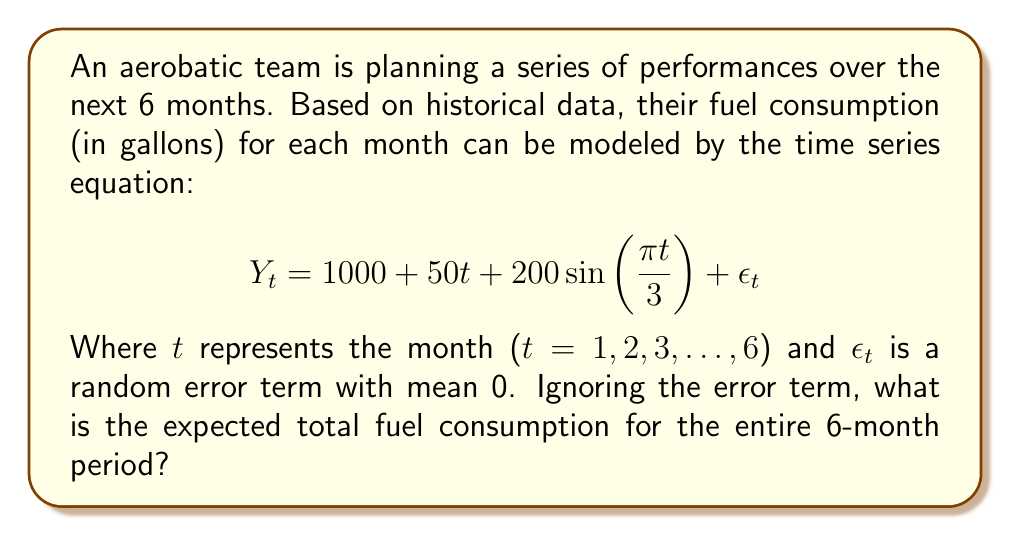Can you solve this math problem? To solve this problem, we need to follow these steps:

1) First, let's understand what each term in the equation represents:
   - 1000 is the base fuel consumption
   - 50t is the linear trend component
   - $200\sin(\frac{\pi t}{3})$ is the seasonal component
   - $\epsilon_t$ is the error term, which we're ignoring as per the question

2) We need to calculate the fuel consumption for each month (t = 1 to 6) and then sum these values.

3) Let's calculate for each month:

   For t = 1:
   $$Y_1 = 1000 + 50(1) + 200\sin(\frac{\pi}{3}) = 1050 + 173.21 = 1223.21$$

   For t = 2:
   $$Y_2 = 1000 + 50(2) + 200\sin(\frac{2\pi}{3}) = 1100 + 173.21 = 1273.21$$

   For t = 3:
   $$Y_3 = 1000 + 50(3) + 200\sin(\pi) = 1150 + 0 = 1150$$

   For t = 4:
   $$Y_4 = 1000 + 50(4) + 200\sin(\frac{4\pi}{3}) = 1200 - 173.21 = 1026.79$$

   For t = 5:
   $$Y_5 = 1000 + 50(5) + 200\sin(\frac{5\pi}{3}) = 1250 - 173.21 = 1076.79$$

   For t = 6:
   $$Y_6 = 1000 + 50(6) + 200\sin(2\pi) = 1300 + 0 = 1300$$

4) Now, we sum all these values:

   $$Total = 1223.21 + 1273.21 + 1150 + 1026.79 + 1076.79 + 1300 = 7050$$

Therefore, the expected total fuel consumption for the entire 6-month period is 7050 gallons.
Answer: 7050 gallons 